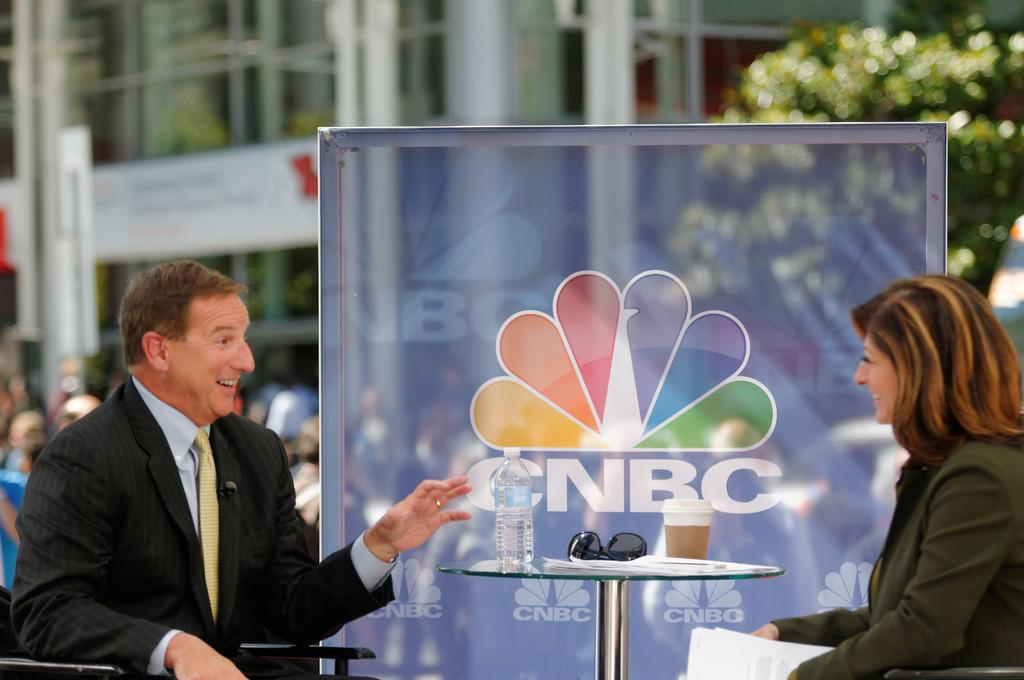What type of structure is present in the image? There is a building in the image. What natural element can be seen in the image? There is a tree in the image. What additional feature is present in the image? There is a banner in the image. What are the people in the image doing? There are people sitting on chairs in the image. What type of accessory is visible in the image? There are goggles in the image. How many legs can be seen on the bird in the image? There is no bird present in the image, so it is not possible to determine the number of legs. 